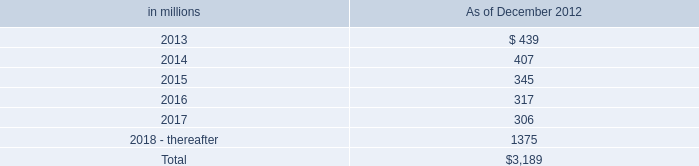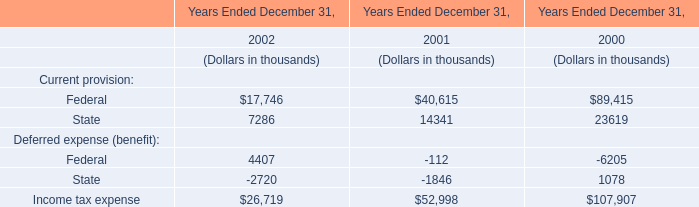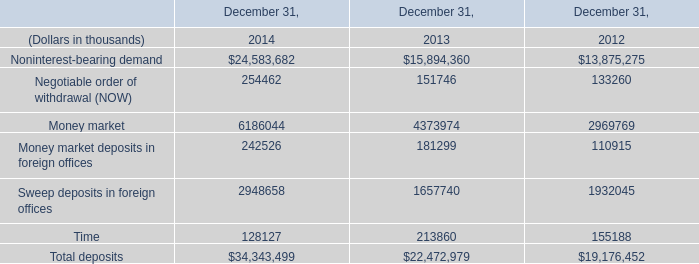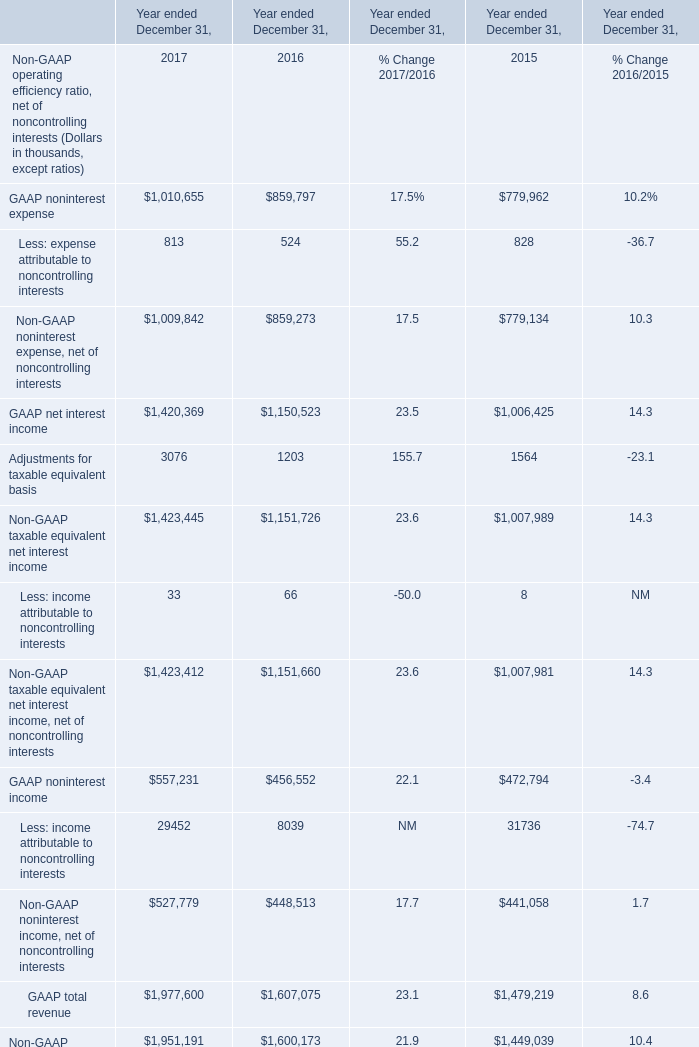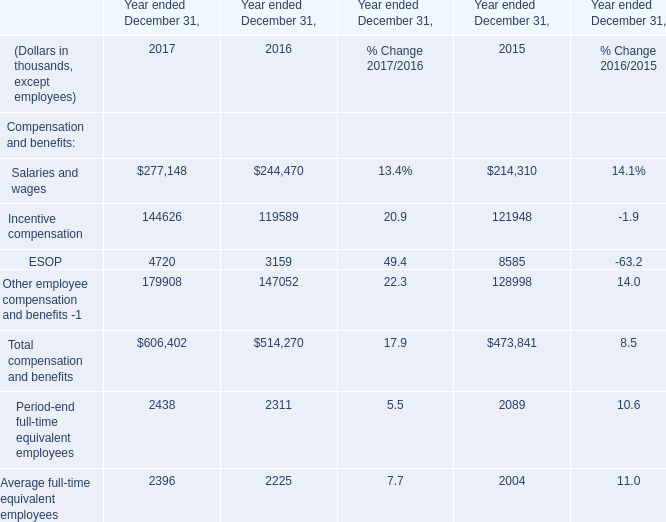what's the total amount of ESOP of Year ended December 31, 2015, GAAP noninterest income of Year ended December 31, 2017, and Salaries and wages of Year ended December 31, 2015 ? 
Computations: ((8585.0 + 557231.0) + 214310.0)
Answer: 780126.0. 